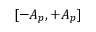Convert formula to latex. <formula><loc_0><loc_0><loc_500><loc_500>[ - A _ { p } , + A _ { p } ]</formula> 